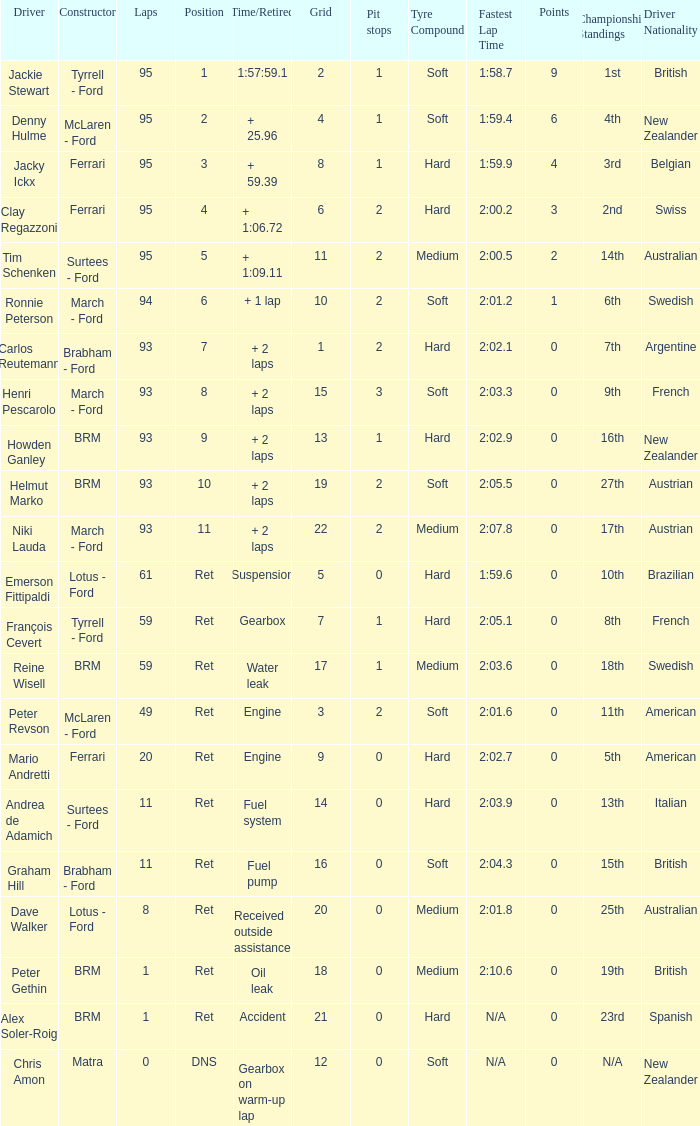With a grid exceeding 14, a time/retired over 2 laps, and helmut marko as the driver, what is the highest number of laps possible? 93.0. 